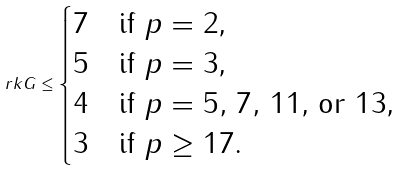<formula> <loc_0><loc_0><loc_500><loc_500>\ r k G \leq \begin{cases} 7 & \text {if $p=2$,} \\ 5 & \text {if $p=3$,} \\ 4 & \text {if $p=5,\, 7,\,11$, or $13$,} \\ 3 & \text {if $p\geq 17$.} \end{cases}</formula> 